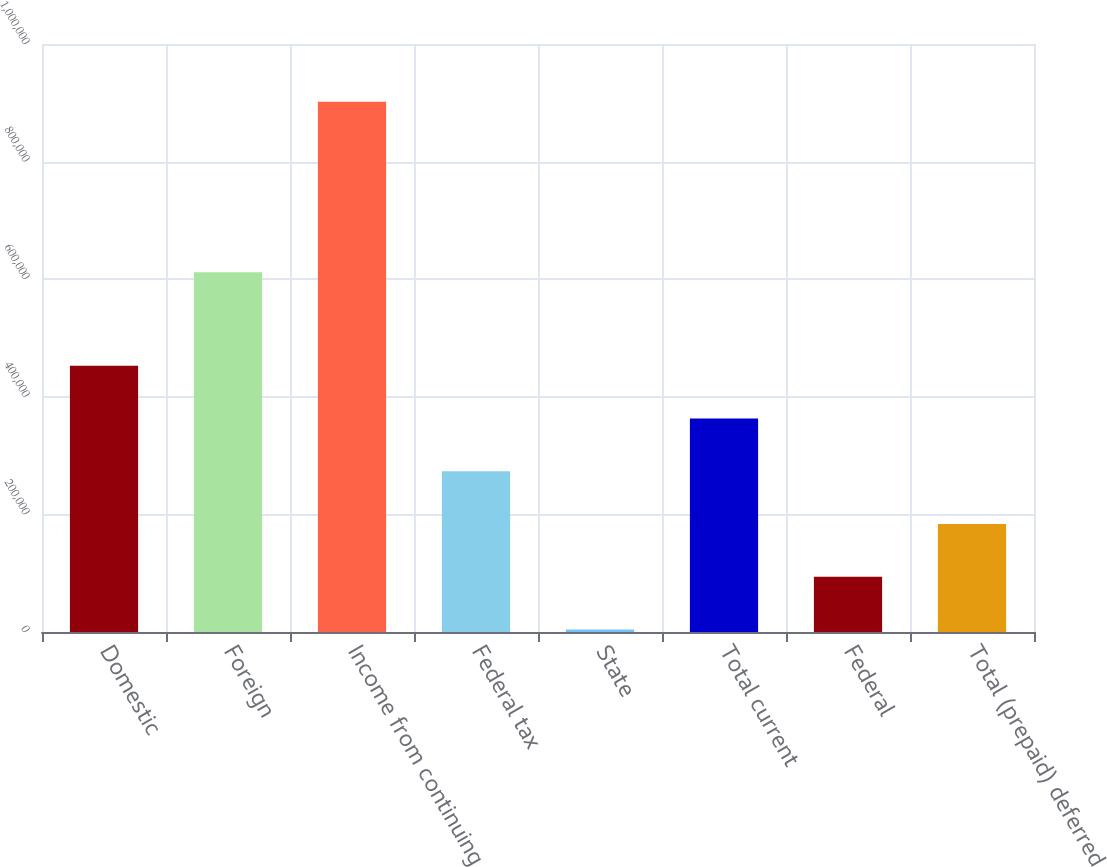Convert chart. <chart><loc_0><loc_0><loc_500><loc_500><bar_chart><fcel>Domestic<fcel>Foreign<fcel>Income from continuing<fcel>Federal tax<fcel>State<fcel>Total current<fcel>Federal<fcel>Total (prepaid) deferred<nl><fcel>452910<fcel>611917<fcel>901665<fcel>273407<fcel>4154<fcel>363158<fcel>93905.1<fcel>183656<nl></chart> 